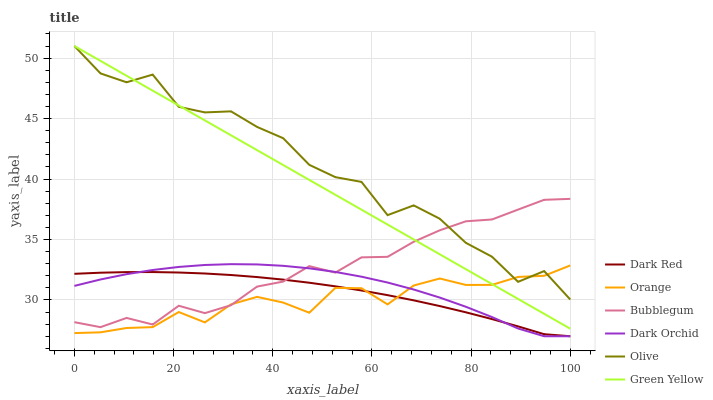Does Orange have the minimum area under the curve?
Answer yes or no. Yes. Does Olive have the maximum area under the curve?
Answer yes or no. Yes. Does Dark Orchid have the minimum area under the curve?
Answer yes or no. No. Does Dark Orchid have the maximum area under the curve?
Answer yes or no. No. Is Green Yellow the smoothest?
Answer yes or no. Yes. Is Olive the roughest?
Answer yes or no. Yes. Is Dark Orchid the smoothest?
Answer yes or no. No. Is Dark Orchid the roughest?
Answer yes or no. No. Does Dark Red have the lowest value?
Answer yes or no. Yes. Does Olive have the lowest value?
Answer yes or no. No. Does Green Yellow have the highest value?
Answer yes or no. Yes. Does Dark Orchid have the highest value?
Answer yes or no. No. Is Dark Orchid less than Green Yellow?
Answer yes or no. Yes. Is Olive greater than Dark Red?
Answer yes or no. Yes. Does Bubblegum intersect Dark Red?
Answer yes or no. Yes. Is Bubblegum less than Dark Red?
Answer yes or no. No. Is Bubblegum greater than Dark Red?
Answer yes or no. No. Does Dark Orchid intersect Green Yellow?
Answer yes or no. No. 